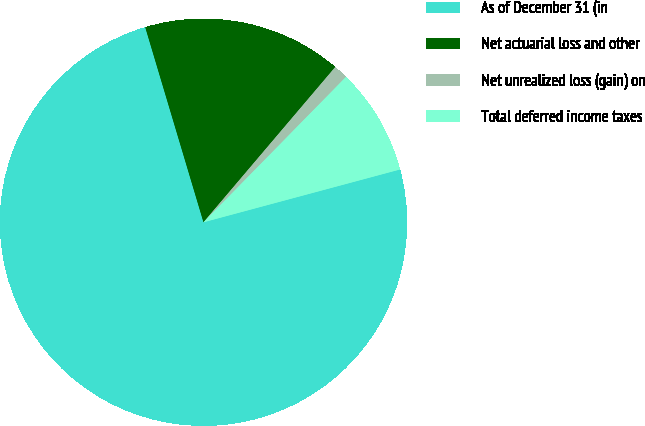Convert chart. <chart><loc_0><loc_0><loc_500><loc_500><pie_chart><fcel>As of December 31 (in<fcel>Net actuarial loss and other<fcel>Net unrealized loss (gain) on<fcel>Total deferred income taxes<nl><fcel>74.55%<fcel>15.82%<fcel>1.14%<fcel>8.48%<nl></chart> 